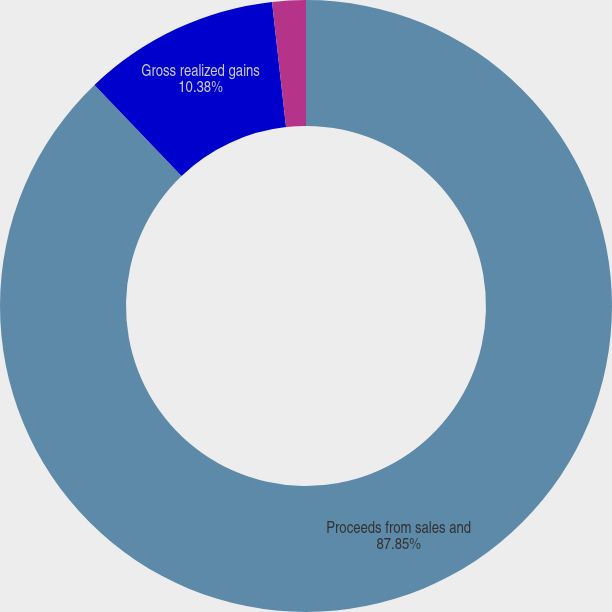Convert chart. <chart><loc_0><loc_0><loc_500><loc_500><pie_chart><fcel>Proceeds from sales and<fcel>Gross realized gains<fcel>Gross realized losses<nl><fcel>87.86%<fcel>10.38%<fcel>1.77%<nl></chart> 